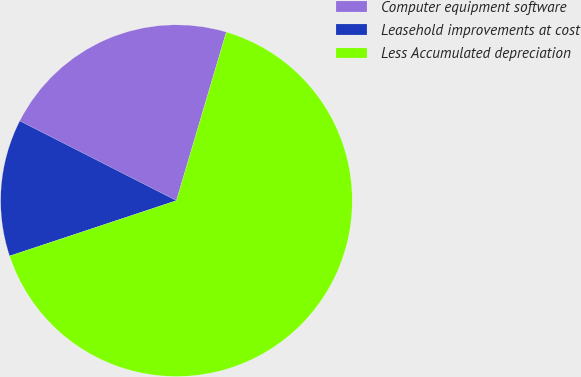<chart> <loc_0><loc_0><loc_500><loc_500><pie_chart><fcel>Computer equipment software<fcel>Leasehold improvements at cost<fcel>Less Accumulated depreciation<nl><fcel>22.09%<fcel>12.59%<fcel>65.32%<nl></chart> 